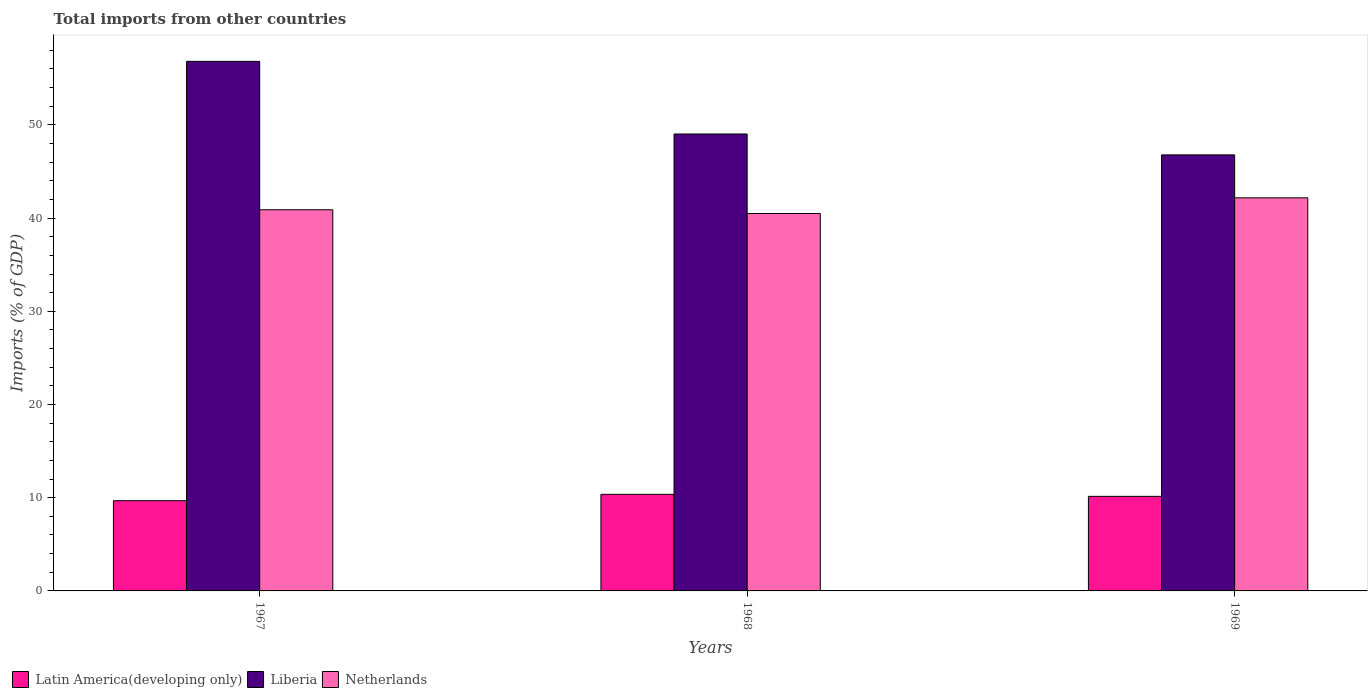How many different coloured bars are there?
Make the answer very short. 3. How many groups of bars are there?
Keep it short and to the point. 3. Are the number of bars per tick equal to the number of legend labels?
Make the answer very short. Yes. How many bars are there on the 2nd tick from the right?
Offer a very short reply. 3. What is the label of the 1st group of bars from the left?
Offer a terse response. 1967. In how many cases, is the number of bars for a given year not equal to the number of legend labels?
Give a very brief answer. 0. What is the total imports in Netherlands in 1969?
Offer a very short reply. 42.17. Across all years, what is the maximum total imports in Latin America(developing only)?
Make the answer very short. 10.36. Across all years, what is the minimum total imports in Netherlands?
Ensure brevity in your answer.  40.49. In which year was the total imports in Netherlands maximum?
Offer a very short reply. 1969. In which year was the total imports in Liberia minimum?
Offer a very short reply. 1969. What is the total total imports in Latin America(developing only) in the graph?
Give a very brief answer. 30.19. What is the difference between the total imports in Latin America(developing only) in 1967 and that in 1968?
Your answer should be very brief. -0.68. What is the difference between the total imports in Netherlands in 1969 and the total imports in Liberia in 1967?
Ensure brevity in your answer.  -14.64. What is the average total imports in Latin America(developing only) per year?
Your answer should be very brief. 10.06. In the year 1969, what is the difference between the total imports in Liberia and total imports in Netherlands?
Keep it short and to the point. 4.61. In how many years, is the total imports in Netherlands greater than 10 %?
Your answer should be very brief. 3. What is the ratio of the total imports in Liberia in 1967 to that in 1968?
Provide a short and direct response. 1.16. Is the total imports in Latin America(developing only) in 1967 less than that in 1969?
Your response must be concise. Yes. What is the difference between the highest and the second highest total imports in Netherlands?
Your response must be concise. 1.28. What is the difference between the highest and the lowest total imports in Liberia?
Keep it short and to the point. 10.03. In how many years, is the total imports in Latin America(developing only) greater than the average total imports in Latin America(developing only) taken over all years?
Ensure brevity in your answer.  2. What does the 2nd bar from the left in 1968 represents?
Keep it short and to the point. Liberia. How many bars are there?
Your answer should be compact. 9. Are all the bars in the graph horizontal?
Give a very brief answer. No. How many years are there in the graph?
Your answer should be compact. 3. How many legend labels are there?
Ensure brevity in your answer.  3. How are the legend labels stacked?
Make the answer very short. Horizontal. What is the title of the graph?
Make the answer very short. Total imports from other countries. What is the label or title of the Y-axis?
Offer a terse response. Imports (% of GDP). What is the Imports (% of GDP) in Latin America(developing only) in 1967?
Offer a terse response. 9.68. What is the Imports (% of GDP) of Liberia in 1967?
Offer a terse response. 56.81. What is the Imports (% of GDP) in Netherlands in 1967?
Provide a succinct answer. 40.89. What is the Imports (% of GDP) in Latin America(developing only) in 1968?
Your answer should be very brief. 10.36. What is the Imports (% of GDP) of Liberia in 1968?
Your answer should be very brief. 49.02. What is the Imports (% of GDP) of Netherlands in 1968?
Offer a very short reply. 40.49. What is the Imports (% of GDP) of Latin America(developing only) in 1969?
Make the answer very short. 10.15. What is the Imports (% of GDP) of Liberia in 1969?
Keep it short and to the point. 46.78. What is the Imports (% of GDP) of Netherlands in 1969?
Give a very brief answer. 42.17. Across all years, what is the maximum Imports (% of GDP) of Latin America(developing only)?
Keep it short and to the point. 10.36. Across all years, what is the maximum Imports (% of GDP) of Liberia?
Make the answer very short. 56.81. Across all years, what is the maximum Imports (% of GDP) in Netherlands?
Offer a terse response. 42.17. Across all years, what is the minimum Imports (% of GDP) of Latin America(developing only)?
Offer a terse response. 9.68. Across all years, what is the minimum Imports (% of GDP) of Liberia?
Ensure brevity in your answer.  46.78. Across all years, what is the minimum Imports (% of GDP) in Netherlands?
Provide a succinct answer. 40.49. What is the total Imports (% of GDP) in Latin America(developing only) in the graph?
Your answer should be compact. 30.19. What is the total Imports (% of GDP) in Liberia in the graph?
Ensure brevity in your answer.  152.62. What is the total Imports (% of GDP) in Netherlands in the graph?
Your response must be concise. 123.56. What is the difference between the Imports (% of GDP) in Latin America(developing only) in 1967 and that in 1968?
Your answer should be very brief. -0.68. What is the difference between the Imports (% of GDP) of Liberia in 1967 and that in 1968?
Your answer should be compact. 7.79. What is the difference between the Imports (% of GDP) of Netherlands in 1967 and that in 1968?
Ensure brevity in your answer.  0.4. What is the difference between the Imports (% of GDP) of Latin America(developing only) in 1967 and that in 1969?
Your answer should be very brief. -0.47. What is the difference between the Imports (% of GDP) in Liberia in 1967 and that in 1969?
Provide a short and direct response. 10.03. What is the difference between the Imports (% of GDP) in Netherlands in 1967 and that in 1969?
Your answer should be very brief. -1.28. What is the difference between the Imports (% of GDP) of Latin America(developing only) in 1968 and that in 1969?
Ensure brevity in your answer.  0.22. What is the difference between the Imports (% of GDP) in Liberia in 1968 and that in 1969?
Ensure brevity in your answer.  2.24. What is the difference between the Imports (% of GDP) of Netherlands in 1968 and that in 1969?
Keep it short and to the point. -1.68. What is the difference between the Imports (% of GDP) in Latin America(developing only) in 1967 and the Imports (% of GDP) in Liberia in 1968?
Provide a short and direct response. -39.34. What is the difference between the Imports (% of GDP) in Latin America(developing only) in 1967 and the Imports (% of GDP) in Netherlands in 1968?
Make the answer very short. -30.81. What is the difference between the Imports (% of GDP) in Liberia in 1967 and the Imports (% of GDP) in Netherlands in 1968?
Give a very brief answer. 16.32. What is the difference between the Imports (% of GDP) of Latin America(developing only) in 1967 and the Imports (% of GDP) of Liberia in 1969?
Offer a very short reply. -37.1. What is the difference between the Imports (% of GDP) of Latin America(developing only) in 1967 and the Imports (% of GDP) of Netherlands in 1969?
Your answer should be very brief. -32.49. What is the difference between the Imports (% of GDP) in Liberia in 1967 and the Imports (% of GDP) in Netherlands in 1969?
Offer a very short reply. 14.64. What is the difference between the Imports (% of GDP) in Latin America(developing only) in 1968 and the Imports (% of GDP) in Liberia in 1969?
Your answer should be compact. -36.42. What is the difference between the Imports (% of GDP) in Latin America(developing only) in 1968 and the Imports (% of GDP) in Netherlands in 1969?
Your response must be concise. -31.81. What is the difference between the Imports (% of GDP) in Liberia in 1968 and the Imports (% of GDP) in Netherlands in 1969?
Offer a very short reply. 6.85. What is the average Imports (% of GDP) in Latin America(developing only) per year?
Ensure brevity in your answer.  10.06. What is the average Imports (% of GDP) of Liberia per year?
Your response must be concise. 50.87. What is the average Imports (% of GDP) in Netherlands per year?
Your answer should be compact. 41.19. In the year 1967, what is the difference between the Imports (% of GDP) of Latin America(developing only) and Imports (% of GDP) of Liberia?
Provide a succinct answer. -47.13. In the year 1967, what is the difference between the Imports (% of GDP) in Latin America(developing only) and Imports (% of GDP) in Netherlands?
Provide a succinct answer. -31.21. In the year 1967, what is the difference between the Imports (% of GDP) of Liberia and Imports (% of GDP) of Netherlands?
Provide a succinct answer. 15.92. In the year 1968, what is the difference between the Imports (% of GDP) of Latin America(developing only) and Imports (% of GDP) of Liberia?
Make the answer very short. -38.66. In the year 1968, what is the difference between the Imports (% of GDP) in Latin America(developing only) and Imports (% of GDP) in Netherlands?
Your response must be concise. -30.13. In the year 1968, what is the difference between the Imports (% of GDP) in Liberia and Imports (% of GDP) in Netherlands?
Your response must be concise. 8.53. In the year 1969, what is the difference between the Imports (% of GDP) of Latin America(developing only) and Imports (% of GDP) of Liberia?
Provide a succinct answer. -36.64. In the year 1969, what is the difference between the Imports (% of GDP) of Latin America(developing only) and Imports (% of GDP) of Netherlands?
Offer a terse response. -32.03. In the year 1969, what is the difference between the Imports (% of GDP) in Liberia and Imports (% of GDP) in Netherlands?
Your answer should be compact. 4.61. What is the ratio of the Imports (% of GDP) in Latin America(developing only) in 1967 to that in 1968?
Provide a succinct answer. 0.93. What is the ratio of the Imports (% of GDP) of Liberia in 1967 to that in 1968?
Keep it short and to the point. 1.16. What is the ratio of the Imports (% of GDP) of Netherlands in 1967 to that in 1968?
Provide a succinct answer. 1.01. What is the ratio of the Imports (% of GDP) of Latin America(developing only) in 1967 to that in 1969?
Your response must be concise. 0.95. What is the ratio of the Imports (% of GDP) in Liberia in 1967 to that in 1969?
Provide a succinct answer. 1.21. What is the ratio of the Imports (% of GDP) of Netherlands in 1967 to that in 1969?
Your response must be concise. 0.97. What is the ratio of the Imports (% of GDP) of Latin America(developing only) in 1968 to that in 1969?
Keep it short and to the point. 1.02. What is the ratio of the Imports (% of GDP) of Liberia in 1968 to that in 1969?
Offer a very short reply. 1.05. What is the ratio of the Imports (% of GDP) in Netherlands in 1968 to that in 1969?
Make the answer very short. 0.96. What is the difference between the highest and the second highest Imports (% of GDP) of Latin America(developing only)?
Your response must be concise. 0.22. What is the difference between the highest and the second highest Imports (% of GDP) in Liberia?
Offer a terse response. 7.79. What is the difference between the highest and the second highest Imports (% of GDP) of Netherlands?
Your response must be concise. 1.28. What is the difference between the highest and the lowest Imports (% of GDP) in Latin America(developing only)?
Keep it short and to the point. 0.68. What is the difference between the highest and the lowest Imports (% of GDP) of Liberia?
Keep it short and to the point. 10.03. What is the difference between the highest and the lowest Imports (% of GDP) of Netherlands?
Provide a succinct answer. 1.68. 